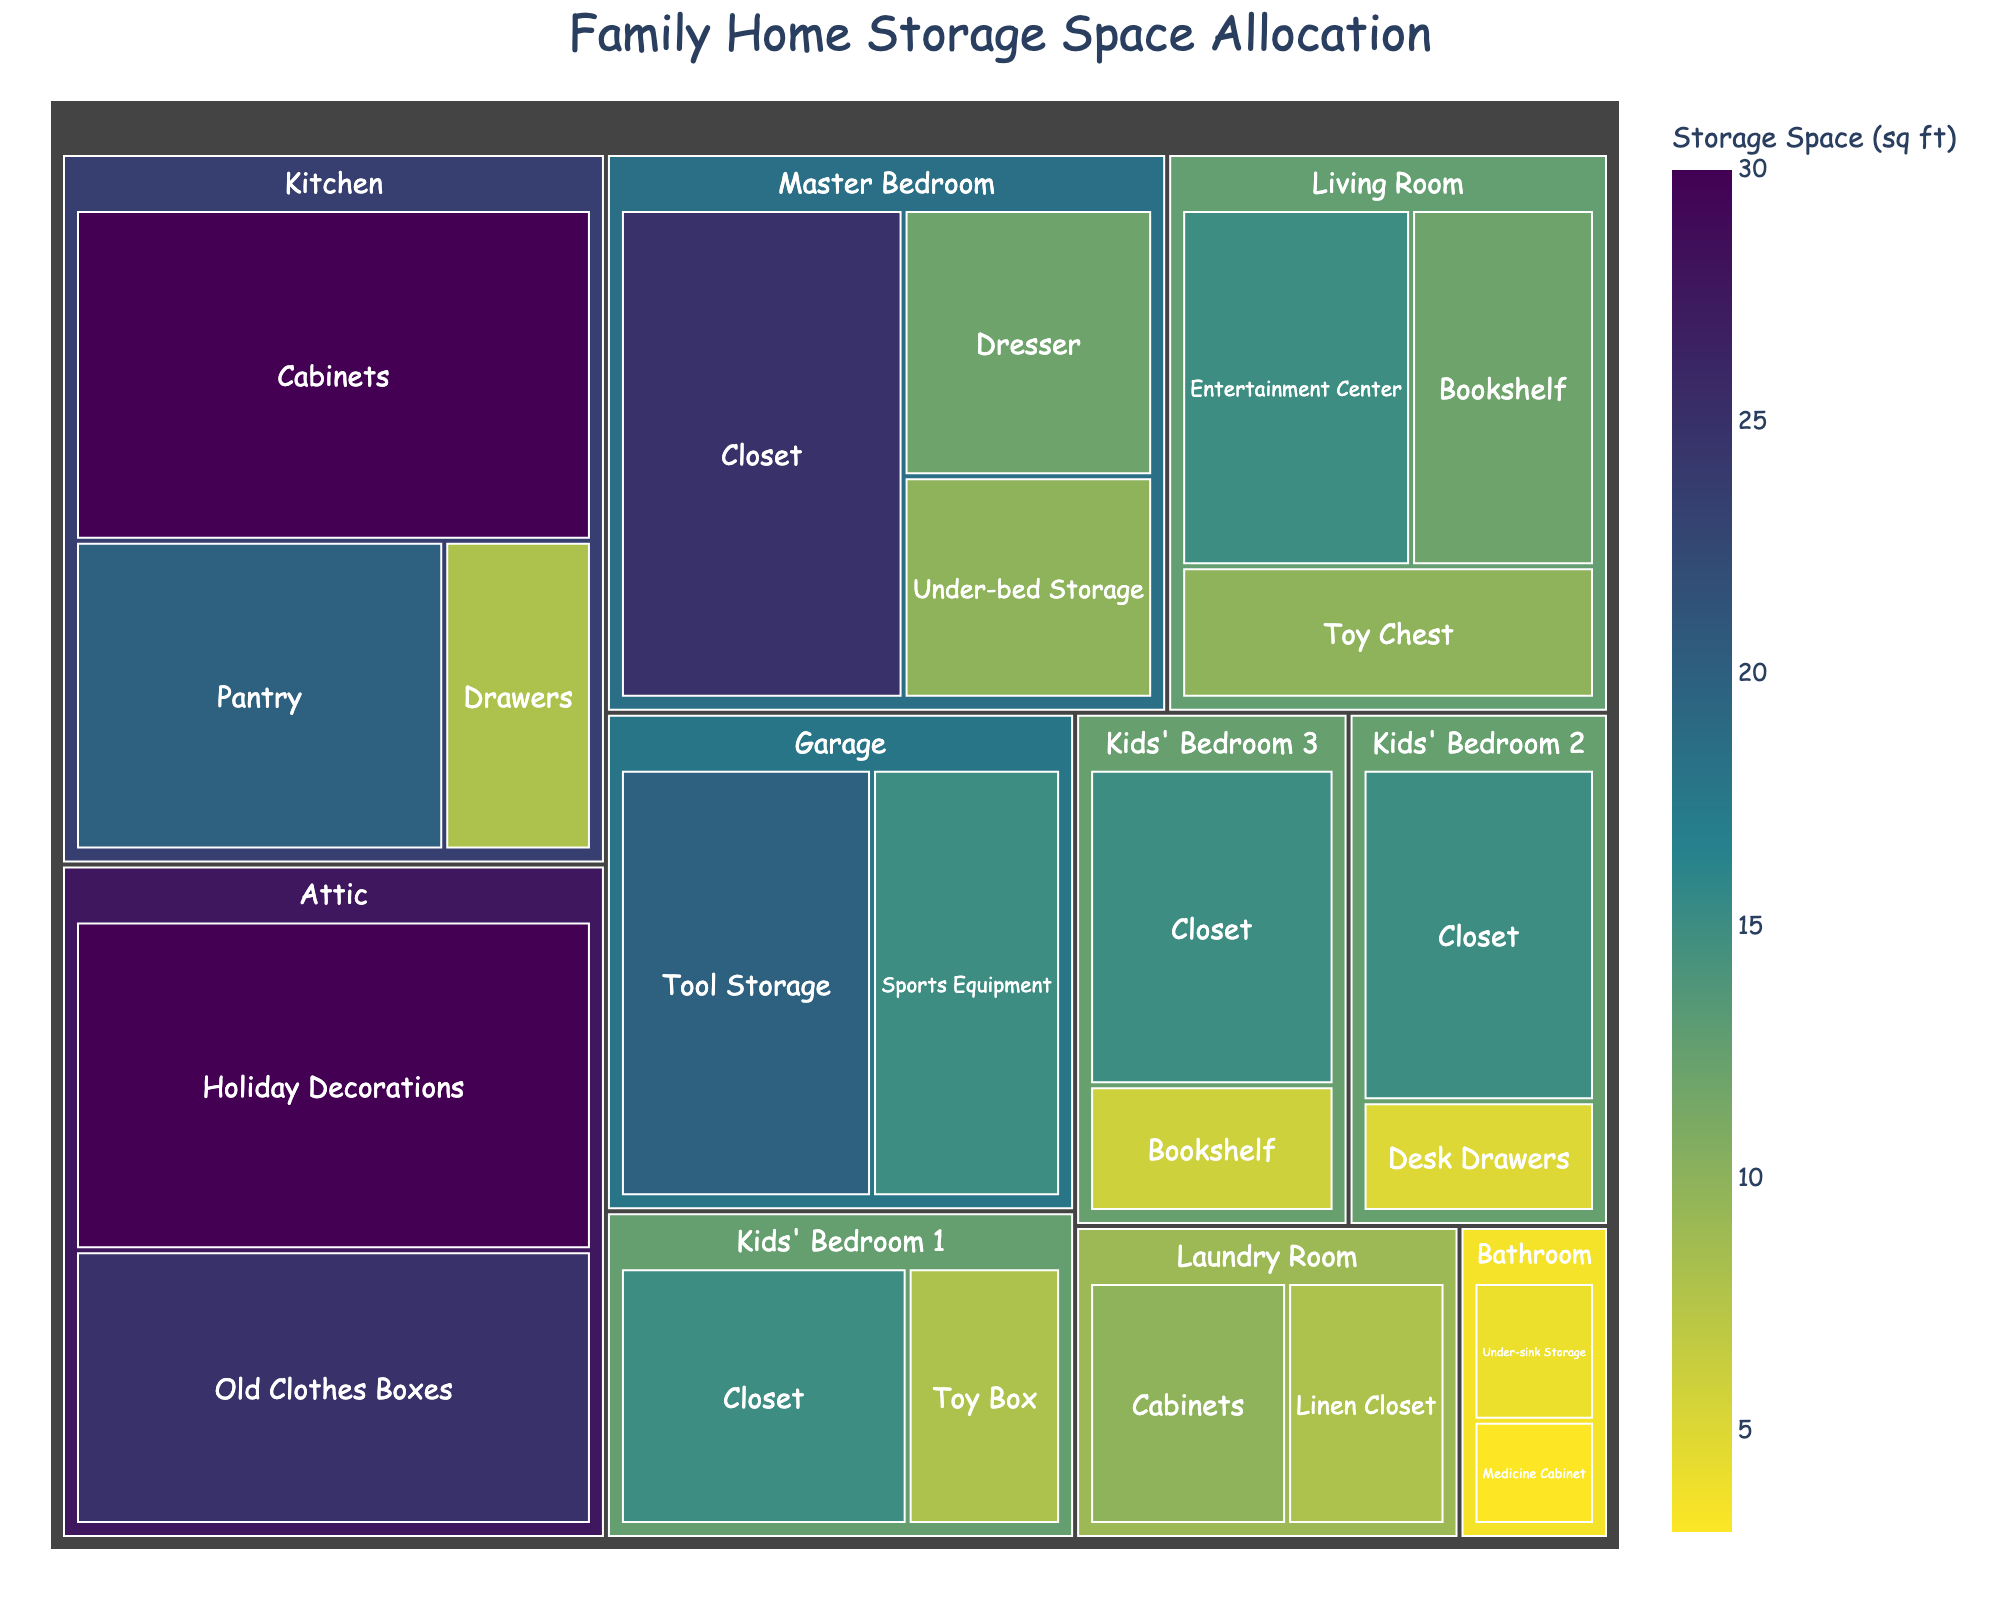What's the title of the Treemap? The title is located at the top center of the Treemap. It is displayed prominently in a larger font size.
Answer: Family Home Storage Space Allocation Which room has the largest total storage space? To determine this, you identify which single room has the largest combined storage space by summing up the square footage of all specific storage areas within each room.
Answer: Kitchen How much storage space is allocated to the Master Bedroom's closet? Locate the 'Master Bedroom' section of the Treemap, and find the 'Closet' sub-section. The amount of storage space is labeled there.
Answer: 25 sq ft Compare the storage space of the Entertainment Center in the Living Room and the Sports Equipment in the Garage. Which has more? Locate both areas in the Treemap. Check the labels for each. The Entertainment Center in the Living Room has 15 sq ft, and the Sports Equipment in the Garage has 15 sq ft. They are equal in storage space.
Answer: They are equal What is the total storage space for all closets in the children's bedrooms? Add the storage spaces for the closets in Kids' Bedroom 1, Kids' Bedroom 2, and Kids' Bedroom 3. Each Closet has 15 sq ft. So, the total is 15 + 15 + 15.
Answer: 45 sq ft Which room has the smallest single storage area? Identify the smallest labeled area in the Treemap by visually finding the smallest rectangle. The Bathroom's Medicine Cabinet, with 3 sq ft, is the smallest.
Answer: Bathroom's Medicine Cabinet What is the total storage space in the Laundry Room? Add the storage space allocated to Cabinets and the Linen Closet in the Laundry Room. They are 10 sq ft and 8 sq ft, respectively.
Answer: 18 sq ft Compare the total storage spaces between the Attic and the Garage. Which room has more storage space? Add up the storage space of all areas in the Attic and the Garage. The Attic has 30 (Holiday Decorations) + 25 (Old Clothes Boxes) = 55 sq ft, and the Garage has 20 (Tool Storage) + 15 (Sports Equipment) = 35 sq ft. The Attic has more.
Answer: Attic What is the difference in storage space between the largest storage area and the smallest storage area? The largest storage area is the Kitchen Cabinets with 30 sq ft, and the smallest is the Bathroom's Medicine Cabinet with 3 sq ft. Subtract the smallest from the largest: 30 - 3.
Answer: 27 sq ft In which room is the toy chest located, and how much storage space does it have? Locate the 'Living Room' section of the Treemap and find the 'Toy Chest' sub-section. The storage space for the Toy Chest is labeled there.
Answer: Living Room, 10 sq ft 